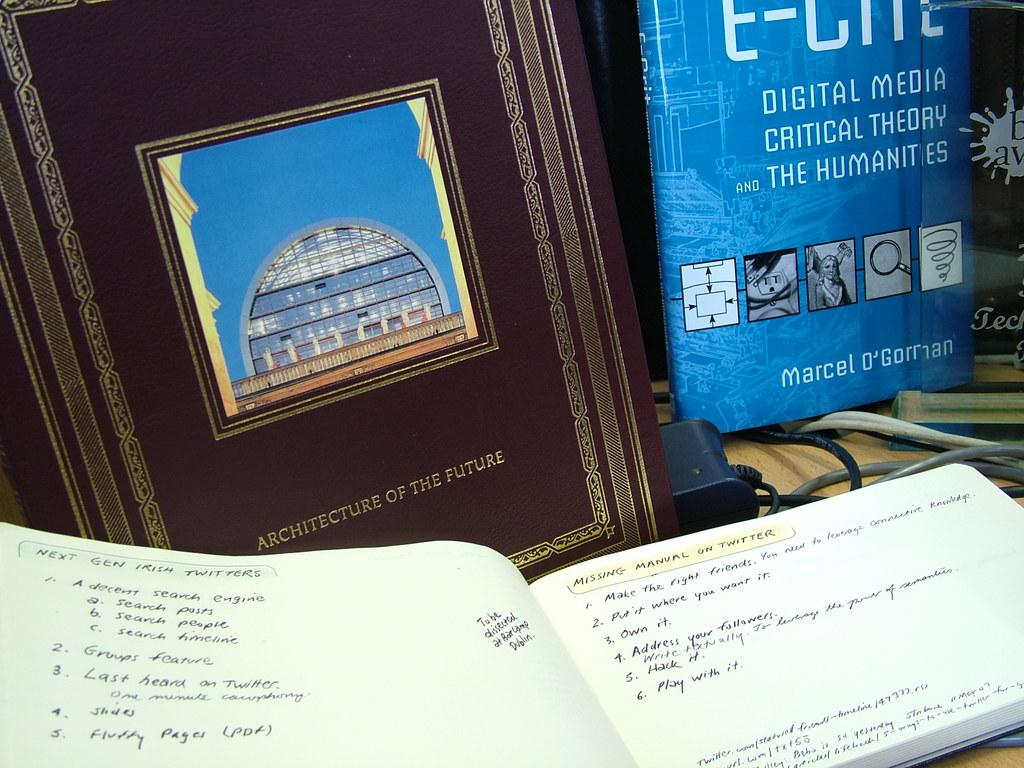<image>
Give a short and clear explanation of the subsequent image. The brown book sitting behind the handwritten book is about Architecture of the future. 